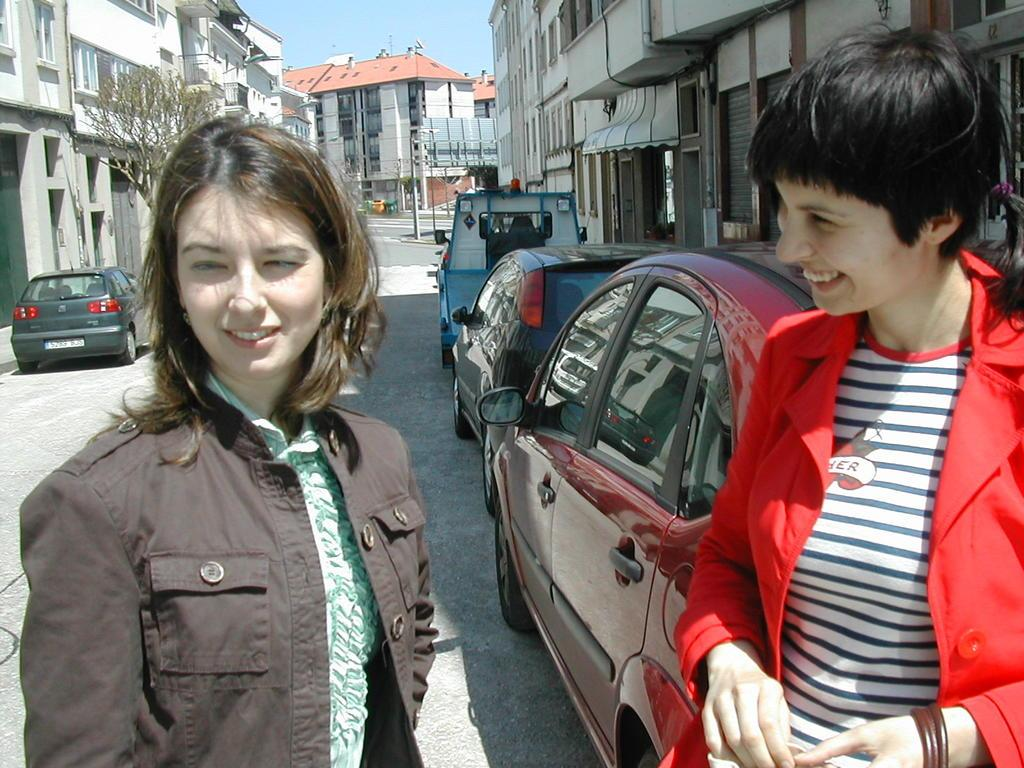How many people are in the image? There are two persons standing in the center of the image. What is the facial expression of the people in the image? The persons are smiling. What can be seen in the background of the image? There are cars, buildings, and a dry tree in the background of the image. Is there any quicksand visible in the image? No, there is no quicksand present in the image. What type of authority figure can be seen in the image? There is no authority figure present in the image. 